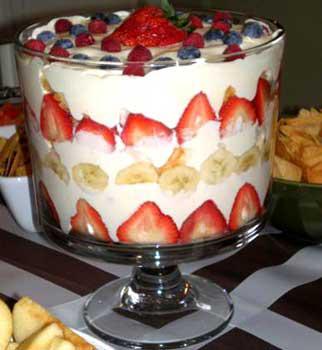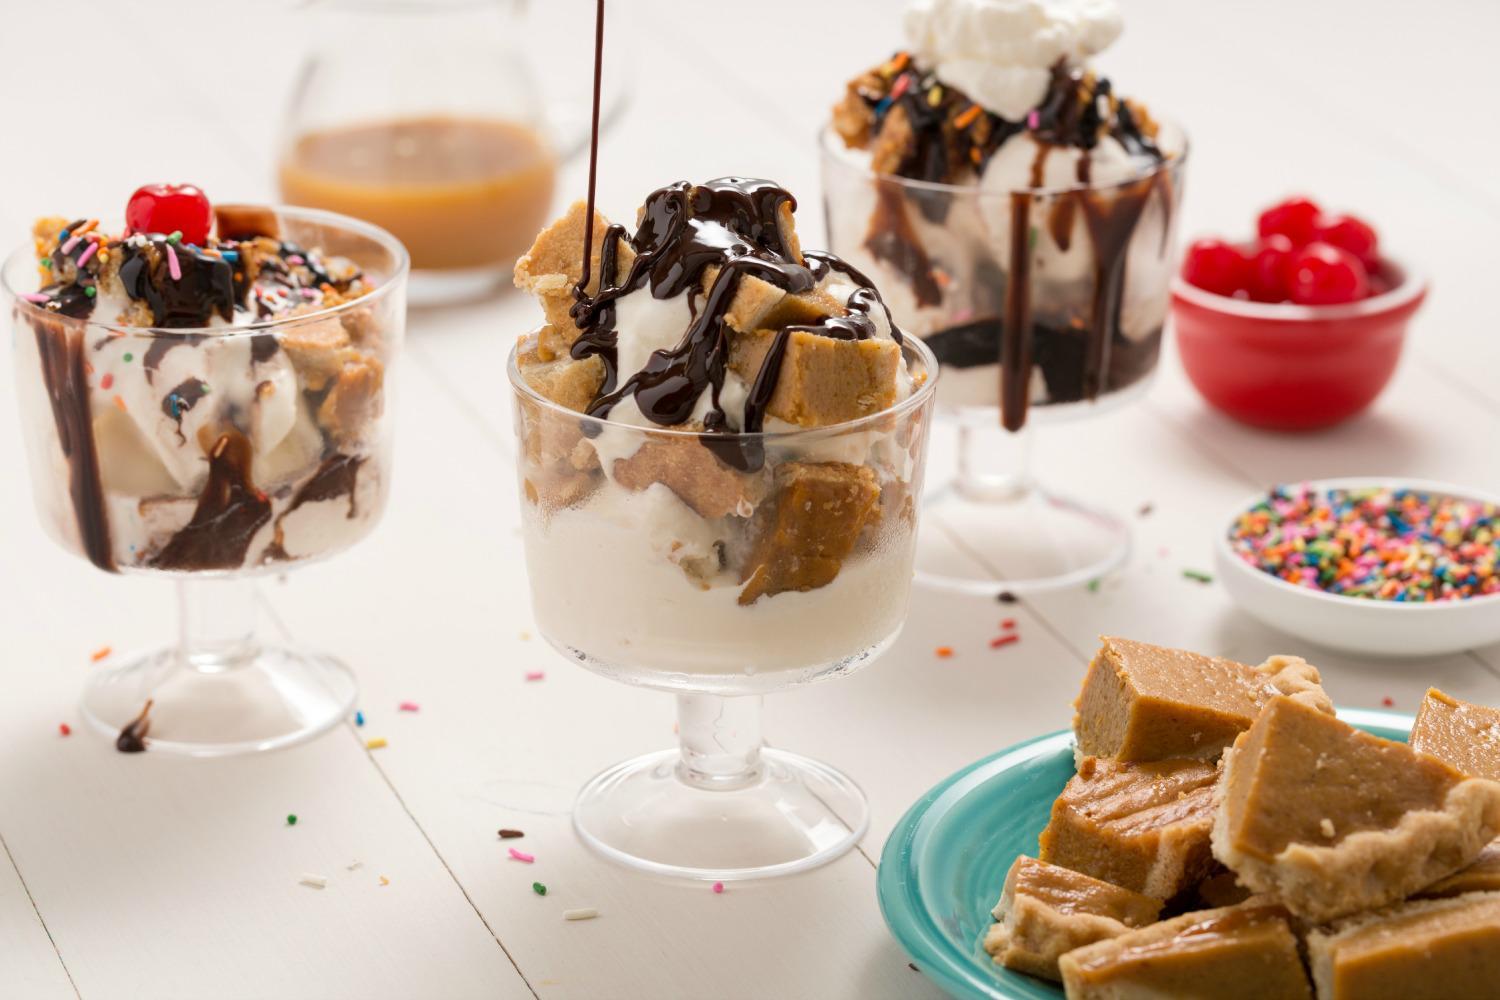The first image is the image on the left, the second image is the image on the right. Given the left and right images, does the statement "One image shows a single large trifle dessert in a footed serving bowl." hold true? Answer yes or no. Yes. 